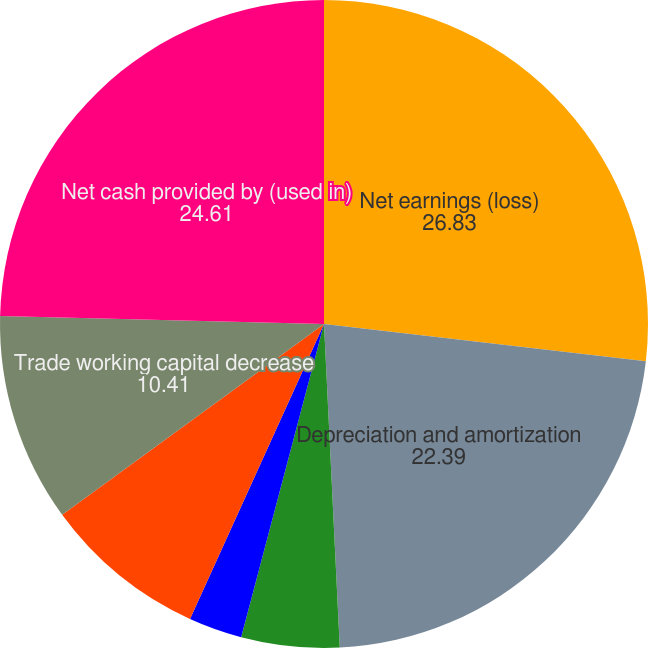<chart> <loc_0><loc_0><loc_500><loc_500><pie_chart><fcel>Net earnings (loss)<fcel>Depreciation and amortization<fcel>Stock-based compensation<fcel>Deferred income taxes<fcel>Retiree benefit funding less<fcel>Trade working capital decrease<fcel>Net cash provided by (used in)<nl><fcel>26.83%<fcel>22.39%<fcel>4.89%<fcel>2.67%<fcel>8.19%<fcel>10.41%<fcel>24.61%<nl></chart> 